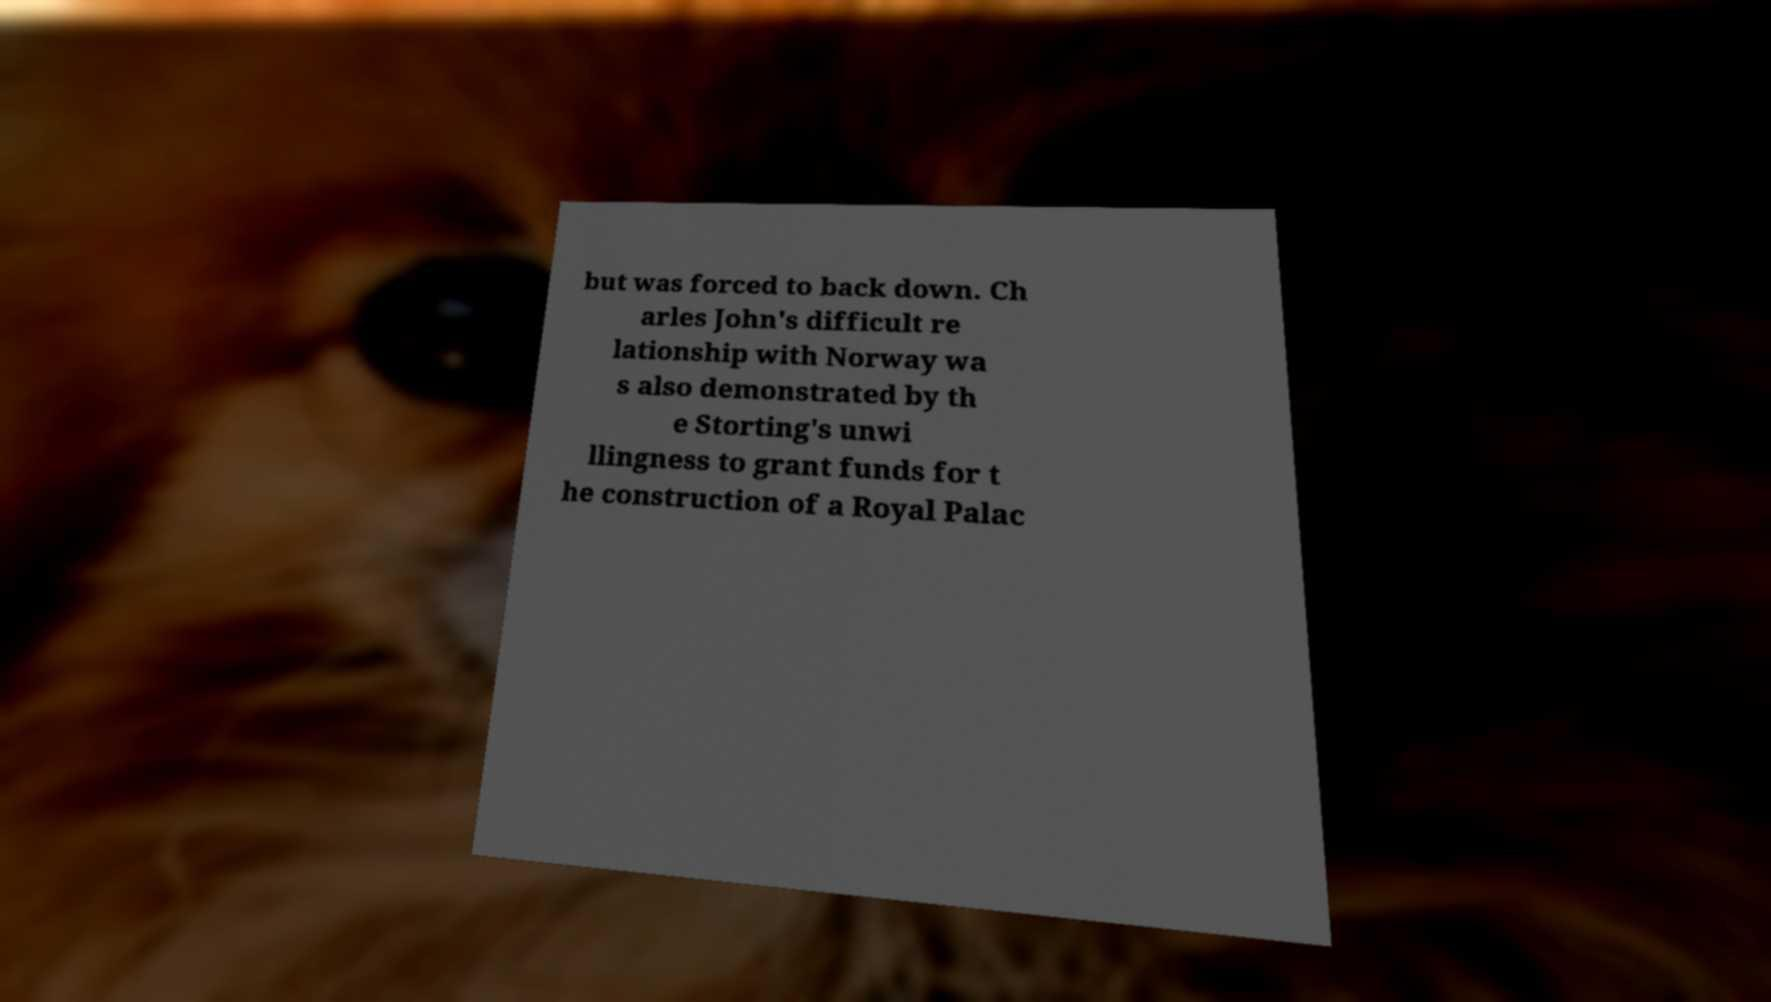I need the written content from this picture converted into text. Can you do that? but was forced to back down. Ch arles John's difficult re lationship with Norway wa s also demonstrated by th e Storting's unwi llingness to grant funds for t he construction of a Royal Palac 